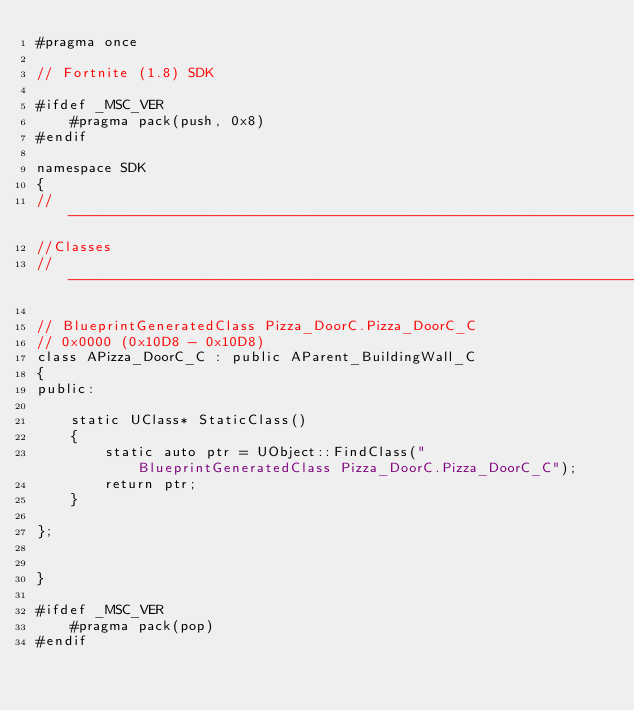Convert code to text. <code><loc_0><loc_0><loc_500><loc_500><_C++_>#pragma once

// Fortnite (1.8) SDK

#ifdef _MSC_VER
	#pragma pack(push, 0x8)
#endif

namespace SDK
{
//---------------------------------------------------------------------------
//Classes
//---------------------------------------------------------------------------

// BlueprintGeneratedClass Pizza_DoorC.Pizza_DoorC_C
// 0x0000 (0x10D8 - 0x10D8)
class APizza_DoorC_C : public AParent_BuildingWall_C
{
public:

	static UClass* StaticClass()
	{
		static auto ptr = UObject::FindClass("BlueprintGeneratedClass Pizza_DoorC.Pizza_DoorC_C");
		return ptr;
	}

};


}

#ifdef _MSC_VER
	#pragma pack(pop)
#endif
</code> 